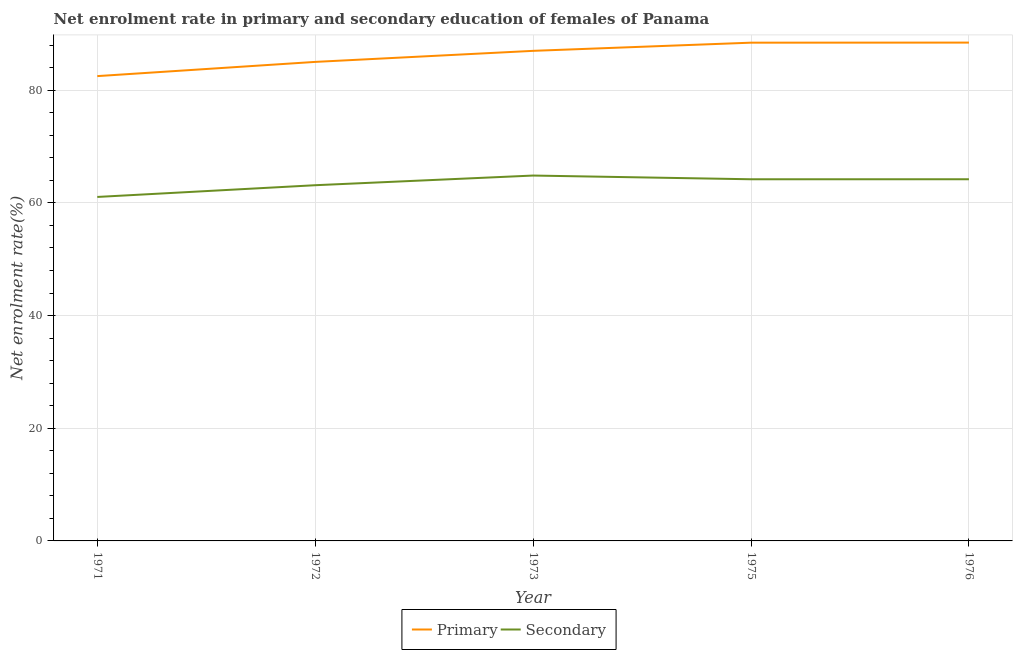How many different coloured lines are there?
Make the answer very short. 2. Does the line corresponding to enrollment rate in secondary education intersect with the line corresponding to enrollment rate in primary education?
Keep it short and to the point. No. Is the number of lines equal to the number of legend labels?
Keep it short and to the point. Yes. What is the enrollment rate in secondary education in 1971?
Provide a succinct answer. 61.05. Across all years, what is the maximum enrollment rate in secondary education?
Your answer should be compact. 64.85. Across all years, what is the minimum enrollment rate in primary education?
Your response must be concise. 82.5. In which year was the enrollment rate in secondary education maximum?
Offer a very short reply. 1973. In which year was the enrollment rate in secondary education minimum?
Keep it short and to the point. 1971. What is the total enrollment rate in primary education in the graph?
Give a very brief answer. 431.38. What is the difference between the enrollment rate in secondary education in 1972 and that in 1976?
Give a very brief answer. -1.06. What is the difference between the enrollment rate in primary education in 1975 and the enrollment rate in secondary education in 1971?
Ensure brevity in your answer.  27.38. What is the average enrollment rate in secondary education per year?
Offer a terse response. 63.48. In the year 1975, what is the difference between the enrollment rate in secondary education and enrollment rate in primary education?
Your answer should be very brief. -24.24. What is the ratio of the enrollment rate in primary education in 1973 to that in 1976?
Your response must be concise. 0.98. Is the enrollment rate in secondary education in 1972 less than that in 1976?
Provide a short and direct response. Yes. What is the difference between the highest and the second highest enrollment rate in primary education?
Ensure brevity in your answer.  0.01. What is the difference between the highest and the lowest enrollment rate in primary education?
Your answer should be compact. 5.95. In how many years, is the enrollment rate in secondary education greater than the average enrollment rate in secondary education taken over all years?
Provide a succinct answer. 3. Is the sum of the enrollment rate in primary education in 1973 and 1975 greater than the maximum enrollment rate in secondary education across all years?
Offer a terse response. Yes. Does the enrollment rate in secondary education monotonically increase over the years?
Provide a short and direct response. No. Is the enrollment rate in primary education strictly greater than the enrollment rate in secondary education over the years?
Your response must be concise. Yes. How many lines are there?
Your answer should be very brief. 2. What is the difference between two consecutive major ticks on the Y-axis?
Offer a very short reply. 20. Are the values on the major ticks of Y-axis written in scientific E-notation?
Make the answer very short. No. Does the graph contain any zero values?
Offer a very short reply. No. Does the graph contain grids?
Provide a succinct answer. Yes. Where does the legend appear in the graph?
Ensure brevity in your answer.  Bottom center. How many legend labels are there?
Make the answer very short. 2. How are the legend labels stacked?
Provide a succinct answer. Horizontal. What is the title of the graph?
Provide a short and direct response. Net enrolment rate in primary and secondary education of females of Panama. Does "Domestic Liabilities" appear as one of the legend labels in the graph?
Your answer should be compact. No. What is the label or title of the Y-axis?
Give a very brief answer. Net enrolment rate(%). What is the Net enrolment rate(%) of Primary in 1971?
Offer a very short reply. 82.5. What is the Net enrolment rate(%) of Secondary in 1971?
Make the answer very short. 61.05. What is the Net enrolment rate(%) of Primary in 1972?
Your answer should be very brief. 85.02. What is the Net enrolment rate(%) of Secondary in 1972?
Give a very brief answer. 63.13. What is the Net enrolment rate(%) in Primary in 1973?
Give a very brief answer. 86.98. What is the Net enrolment rate(%) in Secondary in 1973?
Your answer should be compact. 64.85. What is the Net enrolment rate(%) in Primary in 1975?
Your response must be concise. 88.43. What is the Net enrolment rate(%) in Secondary in 1975?
Keep it short and to the point. 64.19. What is the Net enrolment rate(%) of Primary in 1976?
Keep it short and to the point. 88.45. What is the Net enrolment rate(%) in Secondary in 1976?
Make the answer very short. 64.19. Across all years, what is the maximum Net enrolment rate(%) in Primary?
Ensure brevity in your answer.  88.45. Across all years, what is the maximum Net enrolment rate(%) of Secondary?
Keep it short and to the point. 64.85. Across all years, what is the minimum Net enrolment rate(%) in Primary?
Provide a short and direct response. 82.5. Across all years, what is the minimum Net enrolment rate(%) of Secondary?
Offer a very short reply. 61.05. What is the total Net enrolment rate(%) of Primary in the graph?
Provide a short and direct response. 431.38. What is the total Net enrolment rate(%) of Secondary in the graph?
Give a very brief answer. 317.42. What is the difference between the Net enrolment rate(%) in Primary in 1971 and that in 1972?
Offer a very short reply. -2.52. What is the difference between the Net enrolment rate(%) of Secondary in 1971 and that in 1972?
Offer a terse response. -2.08. What is the difference between the Net enrolment rate(%) of Primary in 1971 and that in 1973?
Ensure brevity in your answer.  -4.48. What is the difference between the Net enrolment rate(%) in Secondary in 1971 and that in 1973?
Your answer should be compact. -3.8. What is the difference between the Net enrolment rate(%) of Primary in 1971 and that in 1975?
Make the answer very short. -5.94. What is the difference between the Net enrolment rate(%) in Secondary in 1971 and that in 1975?
Your answer should be compact. -3.14. What is the difference between the Net enrolment rate(%) of Primary in 1971 and that in 1976?
Your answer should be compact. -5.95. What is the difference between the Net enrolment rate(%) of Secondary in 1971 and that in 1976?
Offer a very short reply. -3.14. What is the difference between the Net enrolment rate(%) of Primary in 1972 and that in 1973?
Your response must be concise. -1.96. What is the difference between the Net enrolment rate(%) of Secondary in 1972 and that in 1973?
Your response must be concise. -1.72. What is the difference between the Net enrolment rate(%) in Primary in 1972 and that in 1975?
Provide a short and direct response. -3.41. What is the difference between the Net enrolment rate(%) in Secondary in 1972 and that in 1975?
Give a very brief answer. -1.06. What is the difference between the Net enrolment rate(%) in Primary in 1972 and that in 1976?
Provide a short and direct response. -3.43. What is the difference between the Net enrolment rate(%) of Secondary in 1972 and that in 1976?
Give a very brief answer. -1.06. What is the difference between the Net enrolment rate(%) in Primary in 1973 and that in 1975?
Provide a short and direct response. -1.45. What is the difference between the Net enrolment rate(%) in Secondary in 1973 and that in 1975?
Ensure brevity in your answer.  0.66. What is the difference between the Net enrolment rate(%) in Primary in 1973 and that in 1976?
Provide a succinct answer. -1.47. What is the difference between the Net enrolment rate(%) of Secondary in 1973 and that in 1976?
Ensure brevity in your answer.  0.66. What is the difference between the Net enrolment rate(%) of Primary in 1975 and that in 1976?
Provide a short and direct response. -0.01. What is the difference between the Net enrolment rate(%) in Secondary in 1975 and that in 1976?
Your answer should be very brief. -0. What is the difference between the Net enrolment rate(%) in Primary in 1971 and the Net enrolment rate(%) in Secondary in 1972?
Keep it short and to the point. 19.36. What is the difference between the Net enrolment rate(%) of Primary in 1971 and the Net enrolment rate(%) of Secondary in 1973?
Provide a succinct answer. 17.65. What is the difference between the Net enrolment rate(%) of Primary in 1971 and the Net enrolment rate(%) of Secondary in 1975?
Provide a succinct answer. 18.31. What is the difference between the Net enrolment rate(%) of Primary in 1971 and the Net enrolment rate(%) of Secondary in 1976?
Give a very brief answer. 18.3. What is the difference between the Net enrolment rate(%) of Primary in 1972 and the Net enrolment rate(%) of Secondary in 1973?
Give a very brief answer. 20.17. What is the difference between the Net enrolment rate(%) of Primary in 1972 and the Net enrolment rate(%) of Secondary in 1975?
Your response must be concise. 20.83. What is the difference between the Net enrolment rate(%) of Primary in 1972 and the Net enrolment rate(%) of Secondary in 1976?
Keep it short and to the point. 20.83. What is the difference between the Net enrolment rate(%) of Primary in 1973 and the Net enrolment rate(%) of Secondary in 1975?
Offer a terse response. 22.79. What is the difference between the Net enrolment rate(%) of Primary in 1973 and the Net enrolment rate(%) of Secondary in 1976?
Ensure brevity in your answer.  22.79. What is the difference between the Net enrolment rate(%) of Primary in 1975 and the Net enrolment rate(%) of Secondary in 1976?
Provide a succinct answer. 24.24. What is the average Net enrolment rate(%) in Primary per year?
Ensure brevity in your answer.  86.28. What is the average Net enrolment rate(%) in Secondary per year?
Your answer should be compact. 63.48. In the year 1971, what is the difference between the Net enrolment rate(%) in Primary and Net enrolment rate(%) in Secondary?
Your answer should be very brief. 21.45. In the year 1972, what is the difference between the Net enrolment rate(%) of Primary and Net enrolment rate(%) of Secondary?
Keep it short and to the point. 21.89. In the year 1973, what is the difference between the Net enrolment rate(%) in Primary and Net enrolment rate(%) in Secondary?
Offer a terse response. 22.13. In the year 1975, what is the difference between the Net enrolment rate(%) in Primary and Net enrolment rate(%) in Secondary?
Your answer should be very brief. 24.24. In the year 1976, what is the difference between the Net enrolment rate(%) in Primary and Net enrolment rate(%) in Secondary?
Provide a short and direct response. 24.25. What is the ratio of the Net enrolment rate(%) of Primary in 1971 to that in 1972?
Your answer should be very brief. 0.97. What is the ratio of the Net enrolment rate(%) in Secondary in 1971 to that in 1972?
Ensure brevity in your answer.  0.97. What is the ratio of the Net enrolment rate(%) of Primary in 1971 to that in 1973?
Ensure brevity in your answer.  0.95. What is the ratio of the Net enrolment rate(%) in Secondary in 1971 to that in 1973?
Keep it short and to the point. 0.94. What is the ratio of the Net enrolment rate(%) of Primary in 1971 to that in 1975?
Your answer should be compact. 0.93. What is the ratio of the Net enrolment rate(%) in Secondary in 1971 to that in 1975?
Your response must be concise. 0.95. What is the ratio of the Net enrolment rate(%) of Primary in 1971 to that in 1976?
Give a very brief answer. 0.93. What is the ratio of the Net enrolment rate(%) in Secondary in 1971 to that in 1976?
Provide a succinct answer. 0.95. What is the ratio of the Net enrolment rate(%) in Primary in 1972 to that in 1973?
Your answer should be very brief. 0.98. What is the ratio of the Net enrolment rate(%) of Secondary in 1972 to that in 1973?
Keep it short and to the point. 0.97. What is the ratio of the Net enrolment rate(%) of Primary in 1972 to that in 1975?
Offer a terse response. 0.96. What is the ratio of the Net enrolment rate(%) of Secondary in 1972 to that in 1975?
Provide a succinct answer. 0.98. What is the ratio of the Net enrolment rate(%) in Primary in 1972 to that in 1976?
Keep it short and to the point. 0.96. What is the ratio of the Net enrolment rate(%) of Secondary in 1972 to that in 1976?
Offer a very short reply. 0.98. What is the ratio of the Net enrolment rate(%) in Primary in 1973 to that in 1975?
Keep it short and to the point. 0.98. What is the ratio of the Net enrolment rate(%) of Secondary in 1973 to that in 1975?
Your response must be concise. 1.01. What is the ratio of the Net enrolment rate(%) of Primary in 1973 to that in 1976?
Provide a short and direct response. 0.98. What is the ratio of the Net enrolment rate(%) in Secondary in 1973 to that in 1976?
Ensure brevity in your answer.  1.01. What is the difference between the highest and the second highest Net enrolment rate(%) of Primary?
Ensure brevity in your answer.  0.01. What is the difference between the highest and the second highest Net enrolment rate(%) of Secondary?
Provide a succinct answer. 0.66. What is the difference between the highest and the lowest Net enrolment rate(%) in Primary?
Offer a terse response. 5.95. What is the difference between the highest and the lowest Net enrolment rate(%) of Secondary?
Your answer should be very brief. 3.8. 